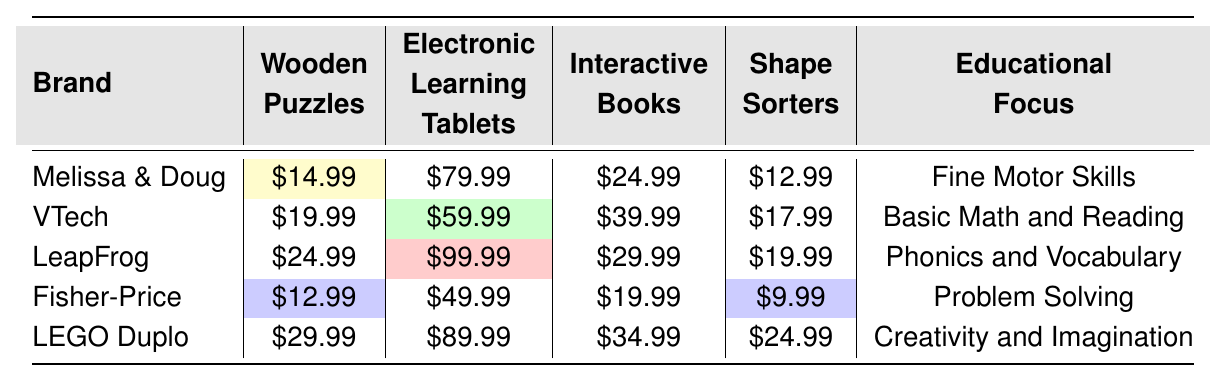What is the price of Wooden Puzzles from LEGO Duplo? The table shows the price of Wooden Puzzles for each brand, and for LEGO Duplo, the price is listed as $29.99.
Answer: $29.99 Which brand offers the most expensive Electronic Learning Tablet? Looking at the prices for Electronic Learning Tablets, LeapFrog has the highest price at $99.99.
Answer: LeapFrog What is the average price of Shape Sorters across all brands? The Shape Sorter prices are $12.99, $17.99, $19.99, $24.99, $34.99. Summing these gives $109.95, and dividing by 5 brands results in an average price of $21.99.
Answer: $21.99 Does Fisher-Price have a product with the lowest price among the brands for any toy type? Observing the prices, Fisher-Price has the lowest price for both Shape Sorters ($9.99) and Wooden Puzzles ($12.99), confirming that it does have the lowest price among the listed brands.
Answer: Yes What is the difference in price between the cheapest and most expensive Interactive Books? The table shows the Interactive Book prices as $24.99 (Melissa & Doug) and $39.99 (VTech). The difference is $39.99 - $24.99 = $15.00.
Answer: $15.00 Which educational focus is associated with the highest rated brand? Analyzing the ratings, LEGO Duplo has the highest rating of 4.8, and its educational focus is Creativity and Imagination.
Answer: Creativity and Imagination Is there any brand that sells both a Wooden Puzzle and an Interactive Book? Checking the table, Melissa & Doug sells both a Wooden Puzzle ($14.99) and an Interactive Book ($24.99), confirming that there are brands with both products.
Answer: Yes Which brand has the lowest average price for all toy types offered? First, calculating the average price for each brand reveals that Fisher-Price averages $17.99, which is lower than all others. Summing its toy prices ($12.99 + $49.99 + $19.99 + $9.99) gives $92.96, and dividing by 4 results in the lowest average.
Answer: Fisher-Price What is the price range for toys from VTech? The prices from VTech are $19.99 (Wooden Puzzles), $59.99 (Electronic Learning Tablets), $39.99 (Interactive Books), $17.99 (Shape Sorters). The lowest price is $17.99 and the highest is $59.99, giving a range of $59.99 - $17.99 = $42.00.
Answer: $42.00 